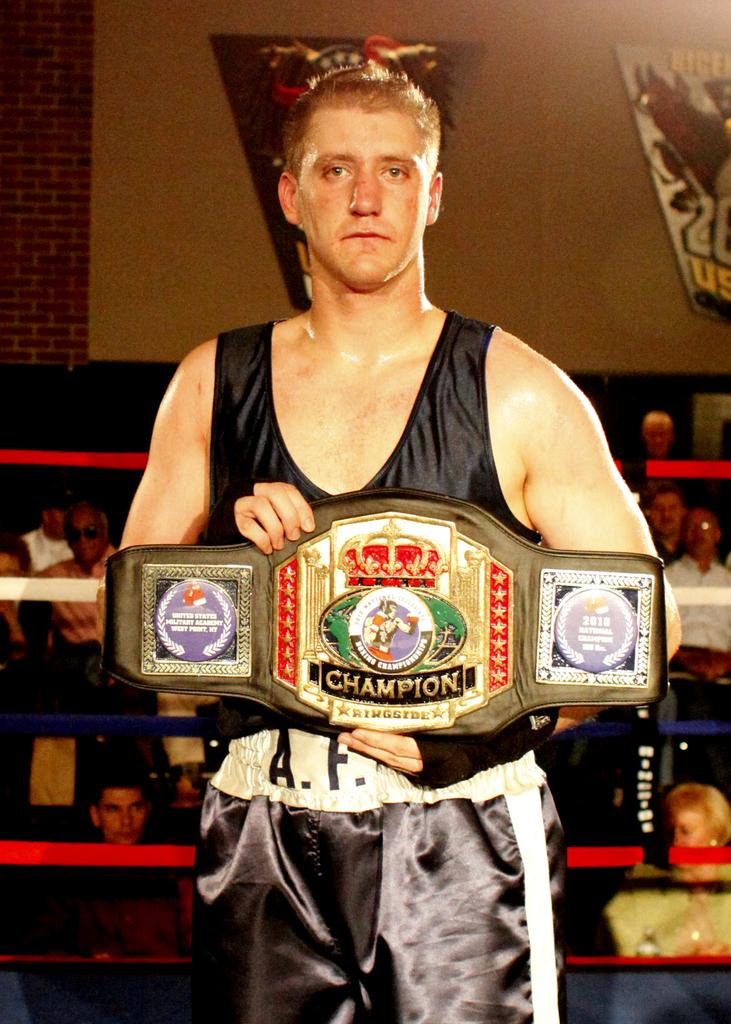<image>
Render a clear and concise summary of the photo. A man holding up a belt that says Champion on it. 